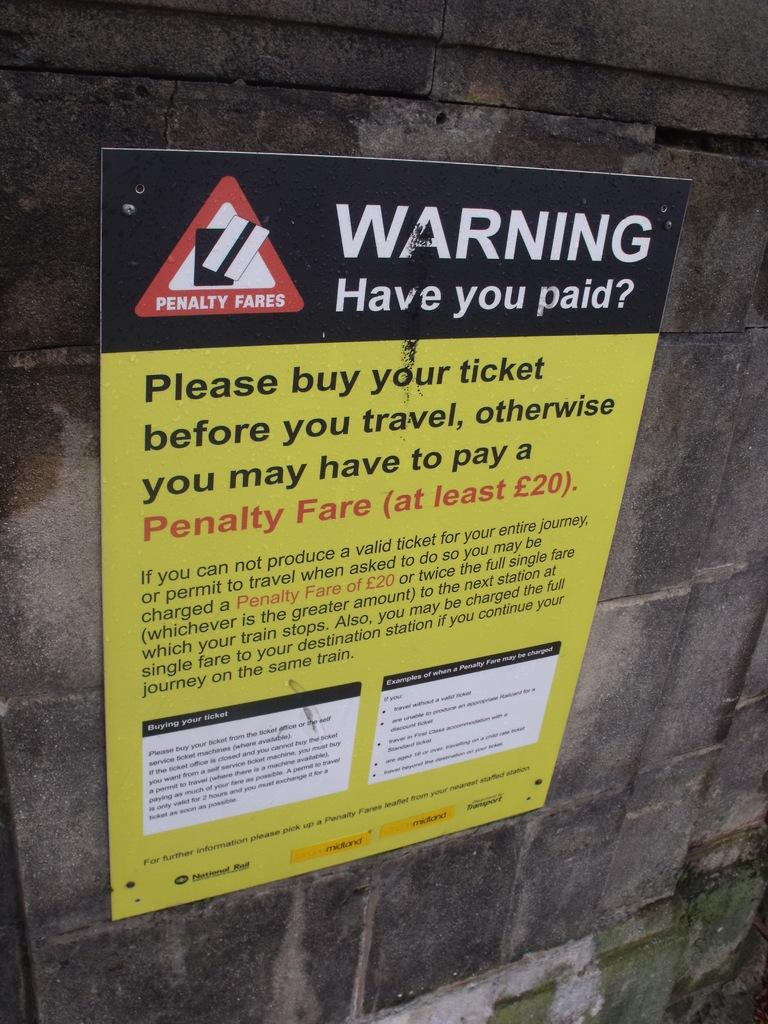<image>
Relay a brief, clear account of the picture shown. A warning advertisement that says, Warning Have you paid. 